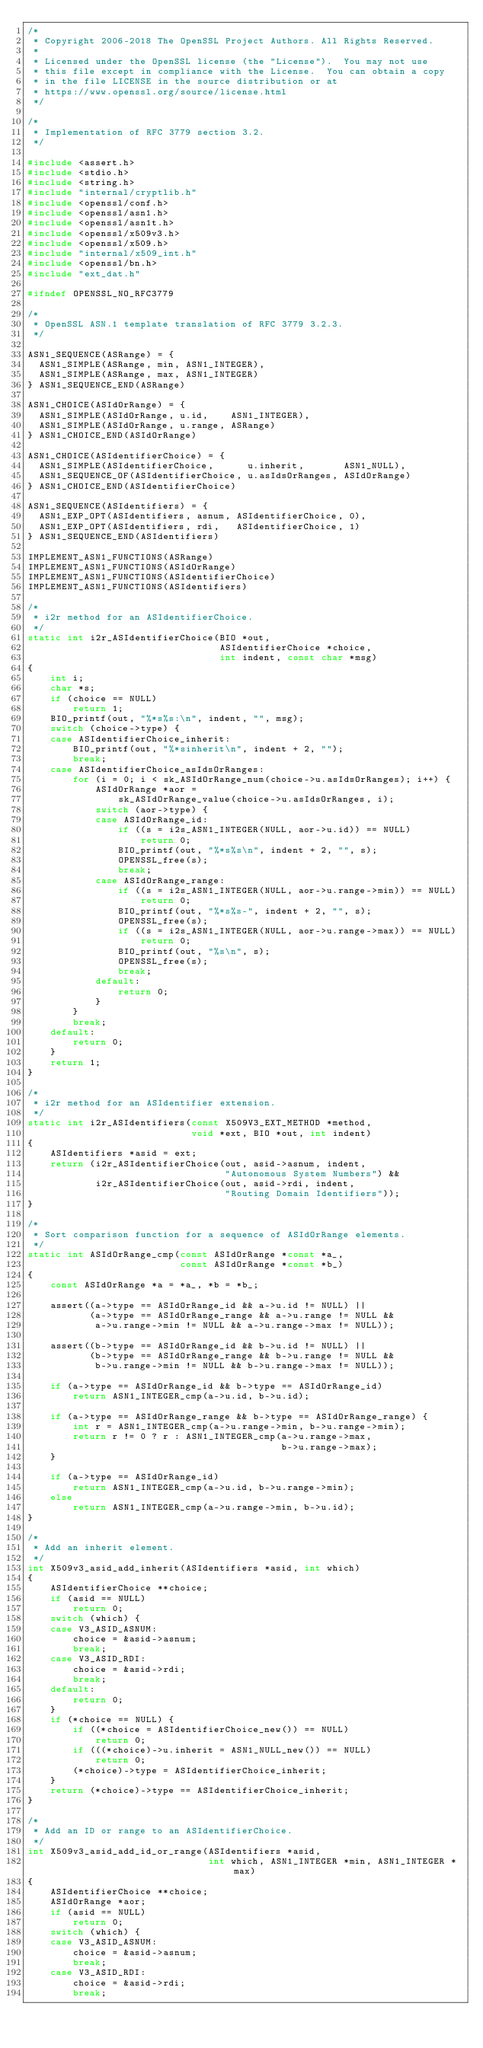<code> <loc_0><loc_0><loc_500><loc_500><_C_>/*
 * Copyright 2006-2018 The OpenSSL Project Authors. All Rights Reserved.
 *
 * Licensed under the OpenSSL license (the "License").  You may not use
 * this file except in compliance with the License.  You can obtain a copy
 * in the file LICENSE in the source distribution or at
 * https://www.openssl.org/source/license.html
 */

/*
 * Implementation of RFC 3779 section 3.2.
 */

#include <assert.h>
#include <stdio.h>
#include <string.h>
#include "internal/cryptlib.h"
#include <openssl/conf.h>
#include <openssl/asn1.h>
#include <openssl/asn1t.h>
#include <openssl/x509v3.h>
#include <openssl/x509.h>
#include "internal/x509_int.h"
#include <openssl/bn.h>
#include "ext_dat.h"

#ifndef OPENSSL_NO_RFC3779

/*
 * OpenSSL ASN.1 template translation of RFC 3779 3.2.3.
 */

ASN1_SEQUENCE(ASRange) = {
  ASN1_SIMPLE(ASRange, min, ASN1_INTEGER),
  ASN1_SIMPLE(ASRange, max, ASN1_INTEGER)
} ASN1_SEQUENCE_END(ASRange)

ASN1_CHOICE(ASIdOrRange) = {
  ASN1_SIMPLE(ASIdOrRange, u.id,    ASN1_INTEGER),
  ASN1_SIMPLE(ASIdOrRange, u.range, ASRange)
} ASN1_CHOICE_END(ASIdOrRange)

ASN1_CHOICE(ASIdentifierChoice) = {
  ASN1_SIMPLE(ASIdentifierChoice,      u.inherit,       ASN1_NULL),
  ASN1_SEQUENCE_OF(ASIdentifierChoice, u.asIdsOrRanges, ASIdOrRange)
} ASN1_CHOICE_END(ASIdentifierChoice)

ASN1_SEQUENCE(ASIdentifiers) = {
  ASN1_EXP_OPT(ASIdentifiers, asnum, ASIdentifierChoice, 0),
  ASN1_EXP_OPT(ASIdentifiers, rdi,   ASIdentifierChoice, 1)
} ASN1_SEQUENCE_END(ASIdentifiers)

IMPLEMENT_ASN1_FUNCTIONS(ASRange)
IMPLEMENT_ASN1_FUNCTIONS(ASIdOrRange)
IMPLEMENT_ASN1_FUNCTIONS(ASIdentifierChoice)
IMPLEMENT_ASN1_FUNCTIONS(ASIdentifiers)

/*
 * i2r method for an ASIdentifierChoice.
 */
static int i2r_ASIdentifierChoice(BIO *out,
                                  ASIdentifierChoice *choice,
                                  int indent, const char *msg)
{
    int i;
    char *s;
    if (choice == NULL)
        return 1;
    BIO_printf(out, "%*s%s:\n", indent, "", msg);
    switch (choice->type) {
    case ASIdentifierChoice_inherit:
        BIO_printf(out, "%*sinherit\n", indent + 2, "");
        break;
    case ASIdentifierChoice_asIdsOrRanges:
        for (i = 0; i < sk_ASIdOrRange_num(choice->u.asIdsOrRanges); i++) {
            ASIdOrRange *aor =
                sk_ASIdOrRange_value(choice->u.asIdsOrRanges, i);
            switch (aor->type) {
            case ASIdOrRange_id:
                if ((s = i2s_ASN1_INTEGER(NULL, aor->u.id)) == NULL)
                    return 0;
                BIO_printf(out, "%*s%s\n", indent + 2, "", s);
                OPENSSL_free(s);
                break;
            case ASIdOrRange_range:
                if ((s = i2s_ASN1_INTEGER(NULL, aor->u.range->min)) == NULL)
                    return 0;
                BIO_printf(out, "%*s%s-", indent + 2, "", s);
                OPENSSL_free(s);
                if ((s = i2s_ASN1_INTEGER(NULL, aor->u.range->max)) == NULL)
                    return 0;
                BIO_printf(out, "%s\n", s);
                OPENSSL_free(s);
                break;
            default:
                return 0;
            }
        }
        break;
    default:
        return 0;
    }
    return 1;
}

/*
 * i2r method for an ASIdentifier extension.
 */
static int i2r_ASIdentifiers(const X509V3_EXT_METHOD *method,
                             void *ext, BIO *out, int indent)
{
    ASIdentifiers *asid = ext;
    return (i2r_ASIdentifierChoice(out, asid->asnum, indent,
                                   "Autonomous System Numbers") &&
            i2r_ASIdentifierChoice(out, asid->rdi, indent,
                                   "Routing Domain Identifiers"));
}

/*
 * Sort comparison function for a sequence of ASIdOrRange elements.
 */
static int ASIdOrRange_cmp(const ASIdOrRange *const *a_,
                           const ASIdOrRange *const *b_)
{
    const ASIdOrRange *a = *a_, *b = *b_;

    assert((a->type == ASIdOrRange_id && a->u.id != NULL) ||
           (a->type == ASIdOrRange_range && a->u.range != NULL &&
            a->u.range->min != NULL && a->u.range->max != NULL));

    assert((b->type == ASIdOrRange_id && b->u.id != NULL) ||
           (b->type == ASIdOrRange_range && b->u.range != NULL &&
            b->u.range->min != NULL && b->u.range->max != NULL));

    if (a->type == ASIdOrRange_id && b->type == ASIdOrRange_id)
        return ASN1_INTEGER_cmp(a->u.id, b->u.id);

    if (a->type == ASIdOrRange_range && b->type == ASIdOrRange_range) {
        int r = ASN1_INTEGER_cmp(a->u.range->min, b->u.range->min);
        return r != 0 ? r : ASN1_INTEGER_cmp(a->u.range->max,
                                             b->u.range->max);
    }

    if (a->type == ASIdOrRange_id)
        return ASN1_INTEGER_cmp(a->u.id, b->u.range->min);
    else
        return ASN1_INTEGER_cmp(a->u.range->min, b->u.id);
}

/*
 * Add an inherit element.
 */
int X509v3_asid_add_inherit(ASIdentifiers *asid, int which)
{
    ASIdentifierChoice **choice;
    if (asid == NULL)
        return 0;
    switch (which) {
    case V3_ASID_ASNUM:
        choice = &asid->asnum;
        break;
    case V3_ASID_RDI:
        choice = &asid->rdi;
        break;
    default:
        return 0;
    }
    if (*choice == NULL) {
        if ((*choice = ASIdentifierChoice_new()) == NULL)
            return 0;
        if (((*choice)->u.inherit = ASN1_NULL_new()) == NULL)
            return 0;
        (*choice)->type = ASIdentifierChoice_inherit;
    }
    return (*choice)->type == ASIdentifierChoice_inherit;
}

/*
 * Add an ID or range to an ASIdentifierChoice.
 */
int X509v3_asid_add_id_or_range(ASIdentifiers *asid,
                                int which, ASN1_INTEGER *min, ASN1_INTEGER *max)
{
    ASIdentifierChoice **choice;
    ASIdOrRange *aor;
    if (asid == NULL)
        return 0;
    switch (which) {
    case V3_ASID_ASNUM:
        choice = &asid->asnum;
        break;
    case V3_ASID_RDI:
        choice = &asid->rdi;
        break;</code> 